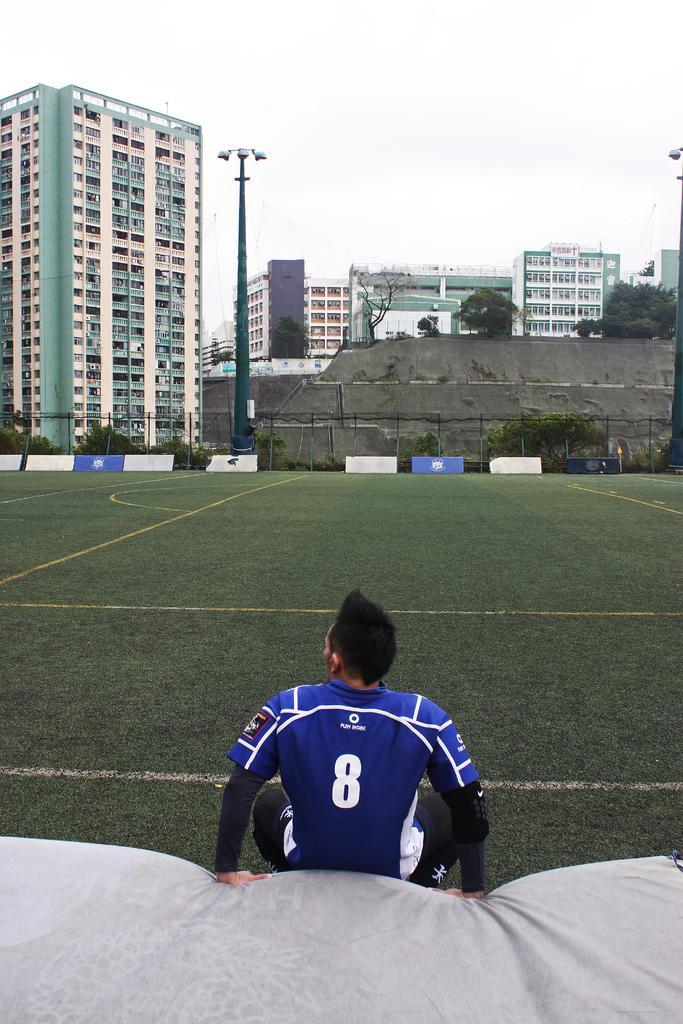Could you give a brief overview of what you see in this image? In this image I can see few buildings, windows, trees, fencing, trees, boards, sky and one person in front. 